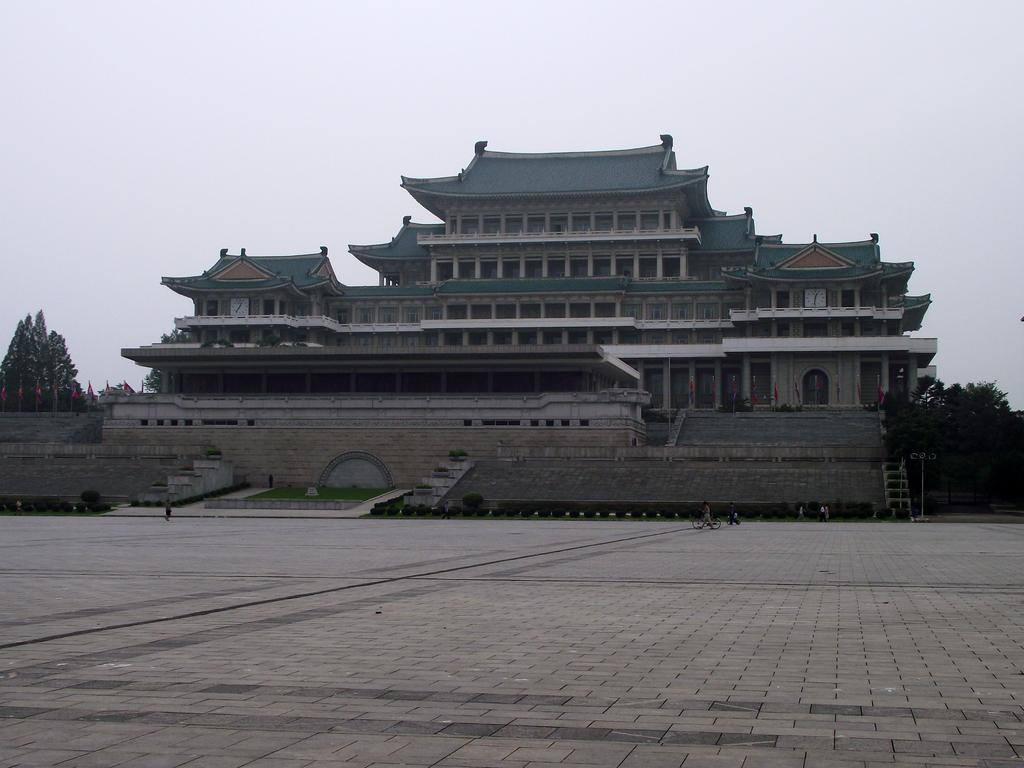What can be seen in the foreground of the image? There is empty land in the foreground of the image. What is visible in the background of the image? There are people, a building structure, trees, and the sky visible in the background of the image. Can you describe the building structure in the background? The building structure is a part of the background, but no specific details about its design or purpose are provided in the facts. What type of vegetation is present in the background? Trees are present in the background of the image. How does the pest affect the society in the image? There is no mention of a pest or society in the image, so it is not possible to answer this question. 